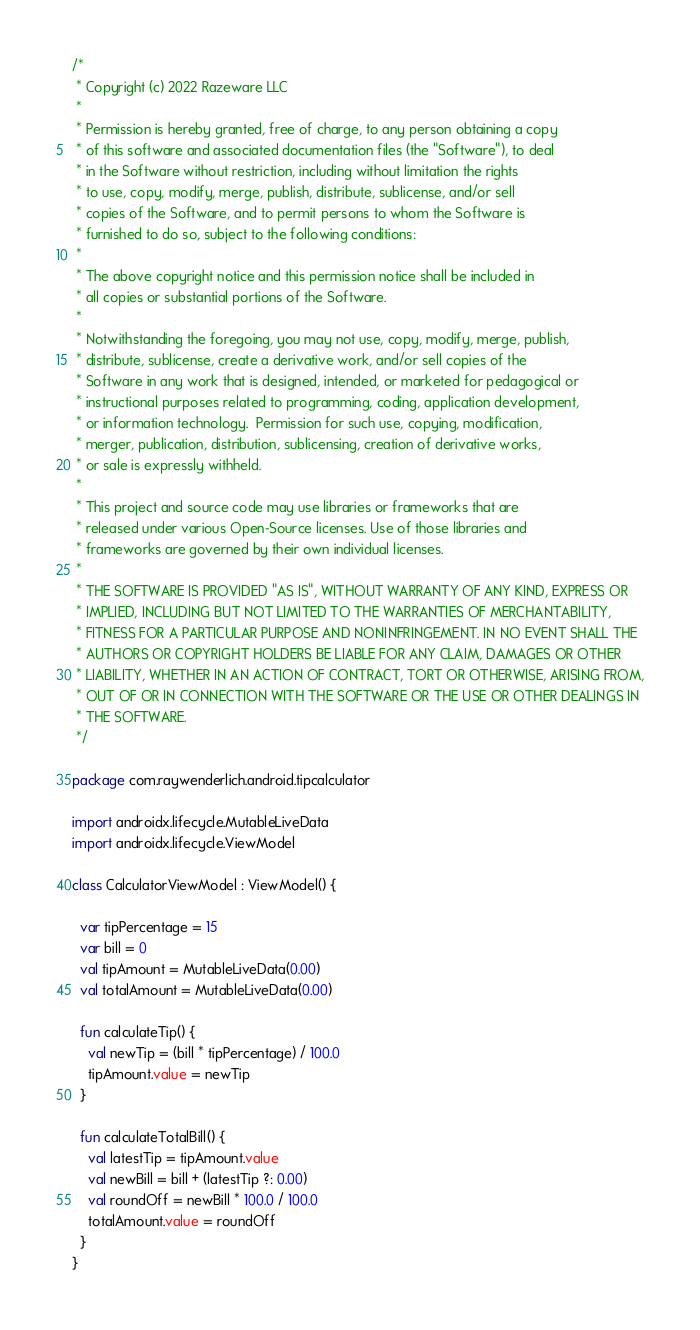Convert code to text. <code><loc_0><loc_0><loc_500><loc_500><_Kotlin_>/*
 * Copyright (c) 2022 Razeware LLC
 *
 * Permission is hereby granted, free of charge, to any person obtaining a copy
 * of this software and associated documentation files (the "Software"), to deal
 * in the Software without restriction, including without limitation the rights
 * to use, copy, modify, merge, publish, distribute, sublicense, and/or sell
 * copies of the Software, and to permit persons to whom the Software is
 * furnished to do so, subject to the following conditions:
 *
 * The above copyright notice and this permission notice shall be included in
 * all copies or substantial portions of the Software.
 *
 * Notwithstanding the foregoing, you may not use, copy, modify, merge, publish,
 * distribute, sublicense, create a derivative work, and/or sell copies of the
 * Software in any work that is designed, intended, or marketed for pedagogical or
 * instructional purposes related to programming, coding, application development,
 * or information technology.  Permission for such use, copying, modification,
 * merger, publication, distribution, sublicensing, creation of derivative works,
 * or sale is expressly withheld.
 *
 * This project and source code may use libraries or frameworks that are
 * released under various Open-Source licenses. Use of those libraries and
 * frameworks are governed by their own individual licenses.
 *
 * THE SOFTWARE IS PROVIDED "AS IS", WITHOUT WARRANTY OF ANY KIND, EXPRESS OR
 * IMPLIED, INCLUDING BUT NOT LIMITED TO THE WARRANTIES OF MERCHANTABILITY,
 * FITNESS FOR A PARTICULAR PURPOSE AND NONINFRINGEMENT. IN NO EVENT SHALL THE
 * AUTHORS OR COPYRIGHT HOLDERS BE LIABLE FOR ANY CLAIM, DAMAGES OR OTHER
 * LIABILITY, WHETHER IN AN ACTION OF CONTRACT, TORT OR OTHERWISE, ARISING FROM,
 * OUT OF OR IN CONNECTION WITH THE SOFTWARE OR THE USE OR OTHER DEALINGS IN
 * THE SOFTWARE.
 */

package com.raywenderlich.android.tipcalculator

import androidx.lifecycle.MutableLiveData
import androidx.lifecycle.ViewModel

class CalculatorViewModel : ViewModel() {

  var tipPercentage = 15
  var bill = 0
  val tipAmount = MutableLiveData(0.00)
  val totalAmount = MutableLiveData(0.00)

  fun calculateTip() {
    val newTip = (bill * tipPercentage) / 100.0
    tipAmount.value = newTip
  }

  fun calculateTotalBill() {
    val latestTip = tipAmount.value
    val newBill = bill + (latestTip ?: 0.00)
    val roundOff = newBill * 100.0 / 100.0
    totalAmount.value = roundOff
  }
}</code> 